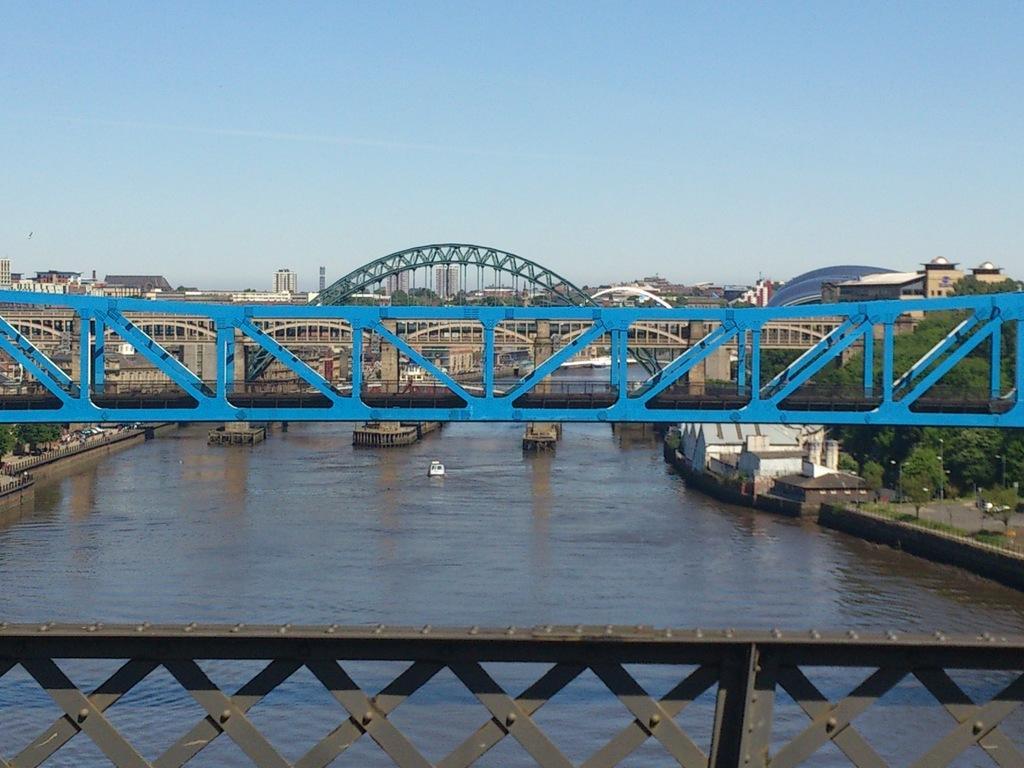Describe this image in one or two sentences. There is a river. Also there is a railing and bridges. On the sides of the river there are trees and buildings. In the background there are buildings and sky. Above the bridge there is an arch. 